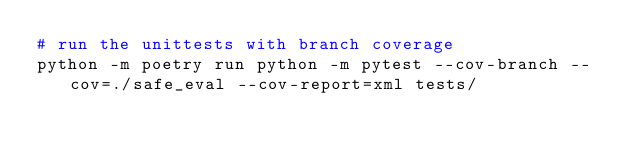Convert code to text. <code><loc_0><loc_0><loc_500><loc_500><_Bash_># run the unittests with branch coverage
python -m poetry run python -m pytest --cov-branch --cov=./safe_eval --cov-report=xml tests/</code> 